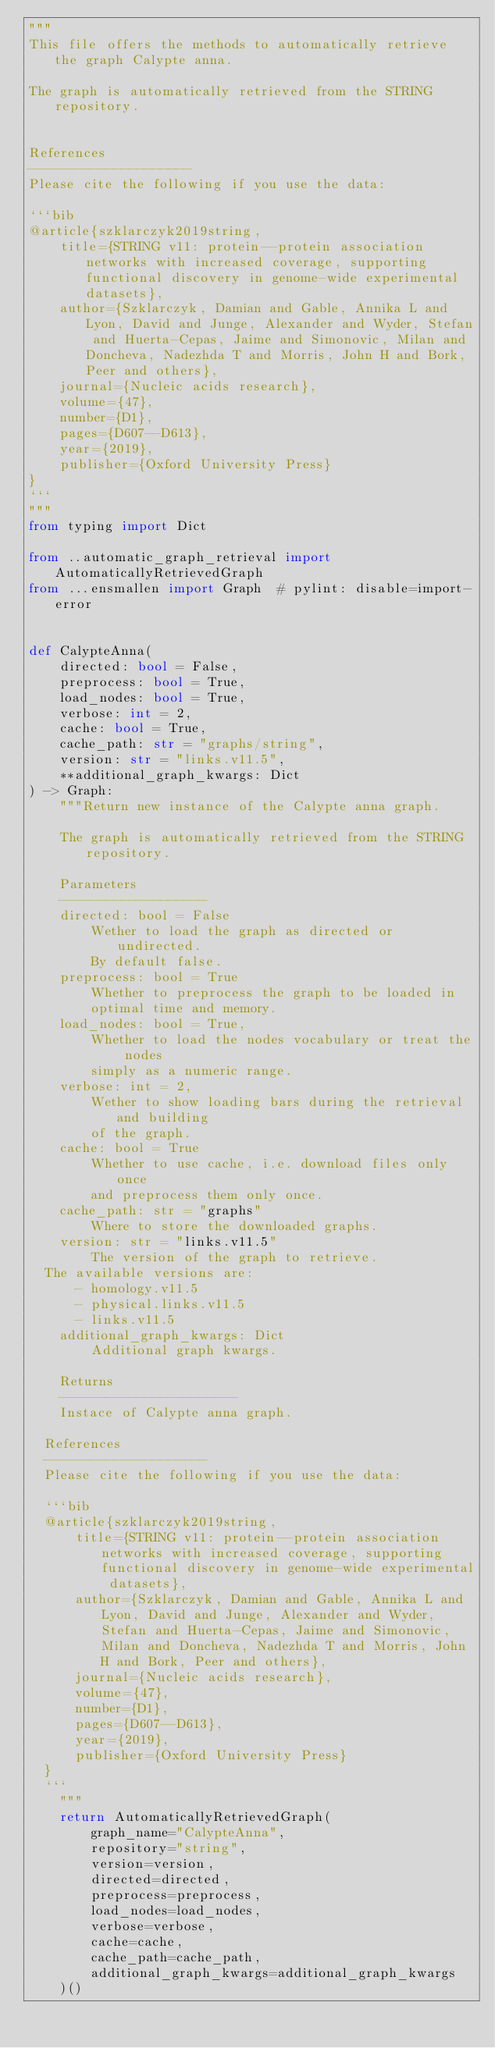<code> <loc_0><loc_0><loc_500><loc_500><_Python_>"""
This file offers the methods to automatically retrieve the graph Calypte anna.

The graph is automatically retrieved from the STRING repository. 


References
---------------------
Please cite the following if you use the data:

```bib
@article{szklarczyk2019string,
    title={STRING v11: protein--protein association networks with increased coverage, supporting functional discovery in genome-wide experimental datasets},
    author={Szklarczyk, Damian and Gable, Annika L and Lyon, David and Junge, Alexander and Wyder, Stefan and Huerta-Cepas, Jaime and Simonovic, Milan and Doncheva, Nadezhda T and Morris, John H and Bork, Peer and others},
    journal={Nucleic acids research},
    volume={47},
    number={D1},
    pages={D607--D613},
    year={2019},
    publisher={Oxford University Press}
}
```
"""
from typing import Dict

from ..automatic_graph_retrieval import AutomaticallyRetrievedGraph
from ...ensmallen import Graph  # pylint: disable=import-error


def CalypteAnna(
    directed: bool = False,
    preprocess: bool = True,
    load_nodes: bool = True,
    verbose: int = 2,
    cache: bool = True,
    cache_path: str = "graphs/string",
    version: str = "links.v11.5",
    **additional_graph_kwargs: Dict
) -> Graph:
    """Return new instance of the Calypte anna graph.

    The graph is automatically retrieved from the STRING repository.	

    Parameters
    -------------------
    directed: bool = False
        Wether to load the graph as directed or undirected.
        By default false.
    preprocess: bool = True
        Whether to preprocess the graph to be loaded in 
        optimal time and memory.
    load_nodes: bool = True,
        Whether to load the nodes vocabulary or treat the nodes
        simply as a numeric range.
    verbose: int = 2,
        Wether to show loading bars during the retrieval and building
        of the graph.
    cache: bool = True
        Whether to use cache, i.e. download files only once
        and preprocess them only once.
    cache_path: str = "graphs"
        Where to store the downloaded graphs.
    version: str = "links.v11.5"
        The version of the graph to retrieve.		
	The available versions are:
			- homology.v11.5
			- physical.links.v11.5
			- links.v11.5
    additional_graph_kwargs: Dict
        Additional graph kwargs.

    Returns
    -----------------------
    Instace of Calypte anna graph.

	References
	---------------------
	Please cite the following if you use the data:
	
	```bib
	@article{szklarczyk2019string,
	    title={STRING v11: protein--protein association networks with increased coverage, supporting functional discovery in genome-wide experimental datasets},
	    author={Szklarczyk, Damian and Gable, Annika L and Lyon, David and Junge, Alexander and Wyder, Stefan and Huerta-Cepas, Jaime and Simonovic, Milan and Doncheva, Nadezhda T and Morris, John H and Bork, Peer and others},
	    journal={Nucleic acids research},
	    volume={47},
	    number={D1},
	    pages={D607--D613},
	    year={2019},
	    publisher={Oxford University Press}
	}
	```
    """
    return AutomaticallyRetrievedGraph(
        graph_name="CalypteAnna",
        repository="string",
        version=version,
        directed=directed,
        preprocess=preprocess,
        load_nodes=load_nodes,
        verbose=verbose,
        cache=cache,
        cache_path=cache_path,
        additional_graph_kwargs=additional_graph_kwargs
    )()
</code> 